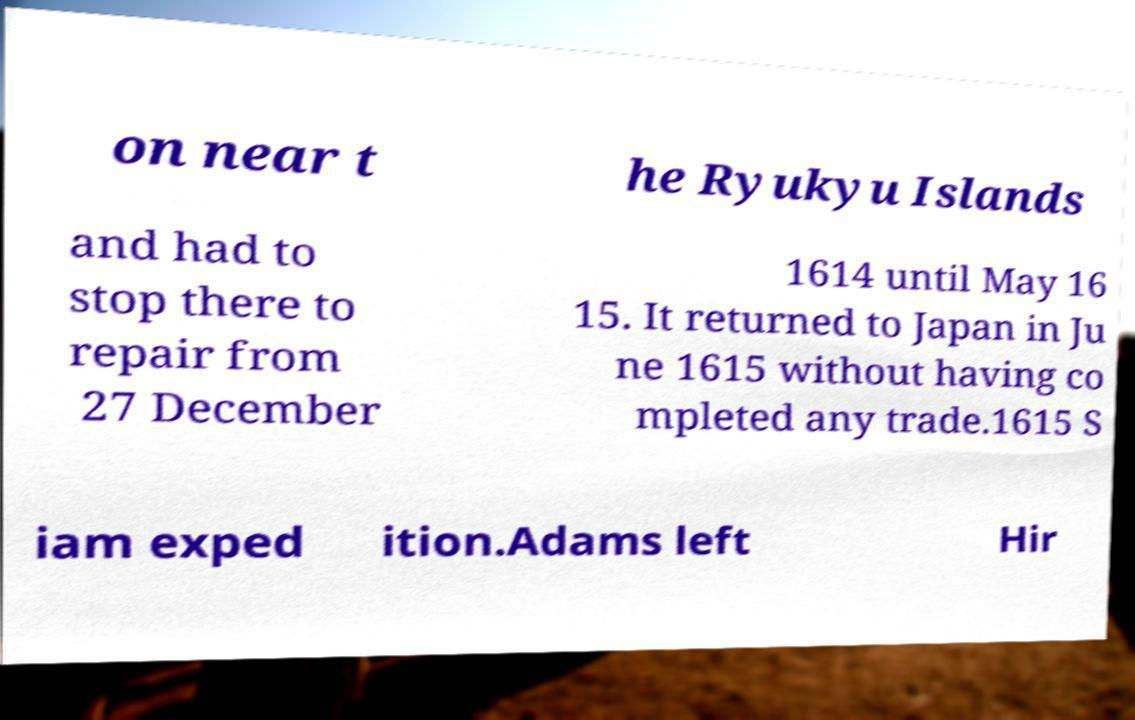There's text embedded in this image that I need extracted. Can you transcribe it verbatim? on near t he Ryukyu Islands and had to stop there to repair from 27 December 1614 until May 16 15. It returned to Japan in Ju ne 1615 without having co mpleted any trade.1615 S iam exped ition.Adams left Hir 